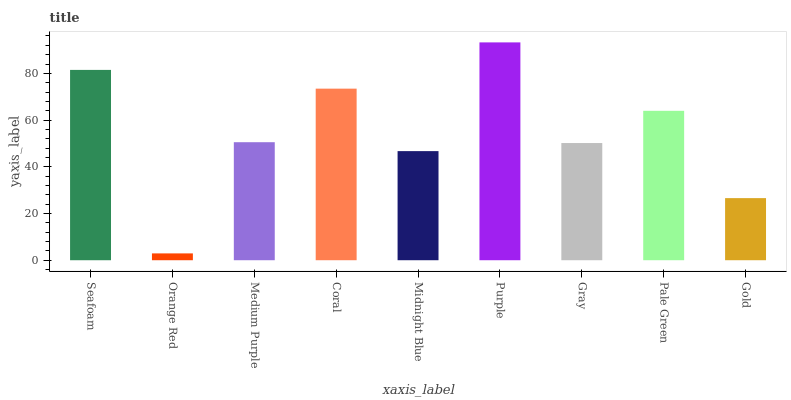Is Orange Red the minimum?
Answer yes or no. Yes. Is Purple the maximum?
Answer yes or no. Yes. Is Medium Purple the minimum?
Answer yes or no. No. Is Medium Purple the maximum?
Answer yes or no. No. Is Medium Purple greater than Orange Red?
Answer yes or no. Yes. Is Orange Red less than Medium Purple?
Answer yes or no. Yes. Is Orange Red greater than Medium Purple?
Answer yes or no. No. Is Medium Purple less than Orange Red?
Answer yes or no. No. Is Medium Purple the high median?
Answer yes or no. Yes. Is Medium Purple the low median?
Answer yes or no. Yes. Is Purple the high median?
Answer yes or no. No. Is Purple the low median?
Answer yes or no. No. 